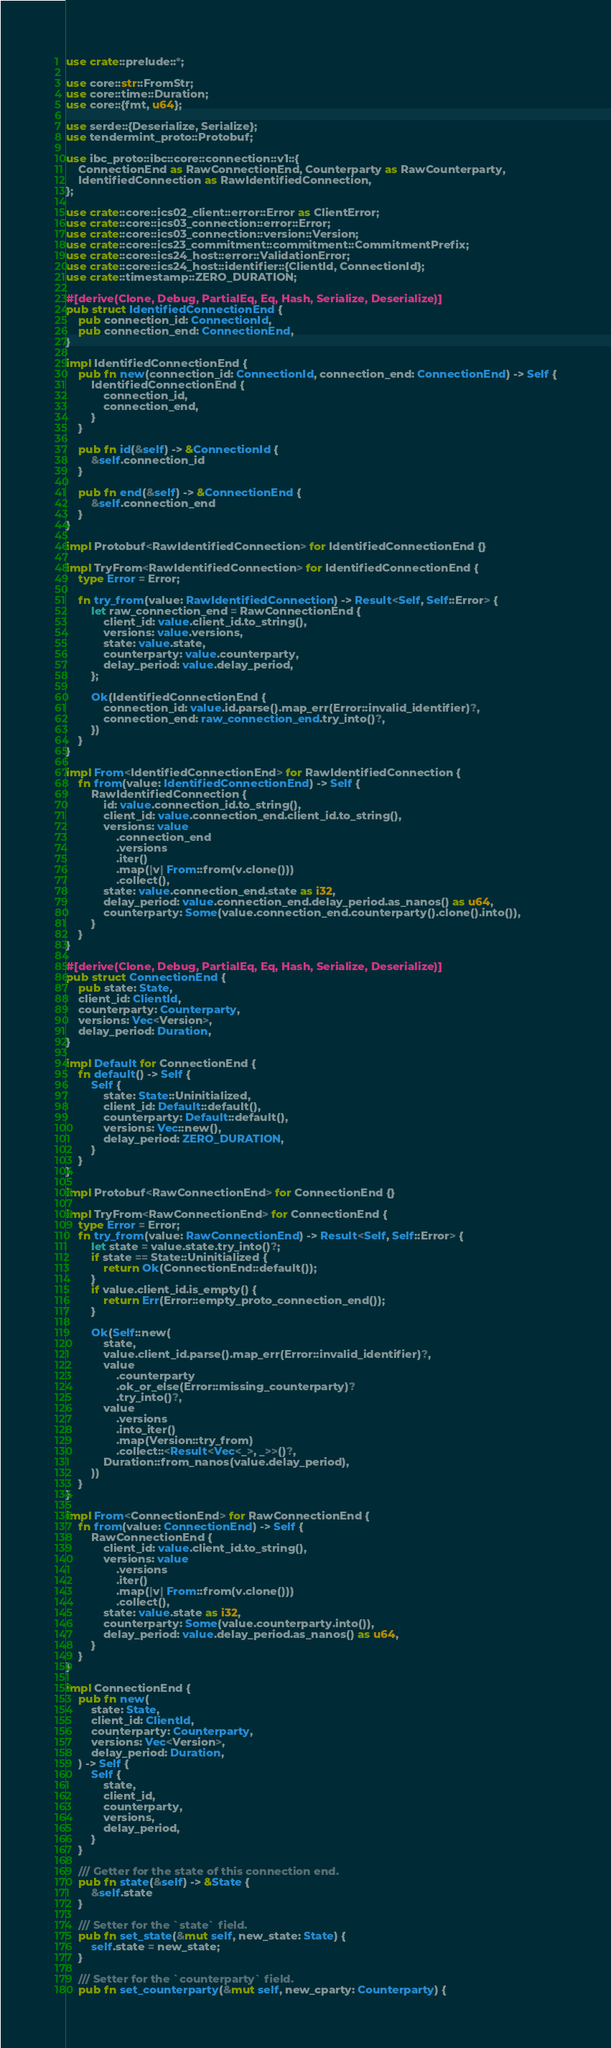Convert code to text. <code><loc_0><loc_0><loc_500><loc_500><_Rust_>use crate::prelude::*;

use core::str::FromStr;
use core::time::Duration;
use core::{fmt, u64};

use serde::{Deserialize, Serialize};
use tendermint_proto::Protobuf;

use ibc_proto::ibc::core::connection::v1::{
    ConnectionEnd as RawConnectionEnd, Counterparty as RawCounterparty,
    IdentifiedConnection as RawIdentifiedConnection,
};

use crate::core::ics02_client::error::Error as ClientError;
use crate::core::ics03_connection::error::Error;
use crate::core::ics03_connection::version::Version;
use crate::core::ics23_commitment::commitment::CommitmentPrefix;
use crate::core::ics24_host::error::ValidationError;
use crate::core::ics24_host::identifier::{ClientId, ConnectionId};
use crate::timestamp::ZERO_DURATION;

#[derive(Clone, Debug, PartialEq, Eq, Hash, Serialize, Deserialize)]
pub struct IdentifiedConnectionEnd {
    pub connection_id: ConnectionId,
    pub connection_end: ConnectionEnd,
}

impl IdentifiedConnectionEnd {
    pub fn new(connection_id: ConnectionId, connection_end: ConnectionEnd) -> Self {
        IdentifiedConnectionEnd {
            connection_id,
            connection_end,
        }
    }

    pub fn id(&self) -> &ConnectionId {
        &self.connection_id
    }

    pub fn end(&self) -> &ConnectionEnd {
        &self.connection_end
    }
}

impl Protobuf<RawIdentifiedConnection> for IdentifiedConnectionEnd {}

impl TryFrom<RawIdentifiedConnection> for IdentifiedConnectionEnd {
    type Error = Error;

    fn try_from(value: RawIdentifiedConnection) -> Result<Self, Self::Error> {
        let raw_connection_end = RawConnectionEnd {
            client_id: value.client_id.to_string(),
            versions: value.versions,
            state: value.state,
            counterparty: value.counterparty,
            delay_period: value.delay_period,
        };

        Ok(IdentifiedConnectionEnd {
            connection_id: value.id.parse().map_err(Error::invalid_identifier)?,
            connection_end: raw_connection_end.try_into()?,
        })
    }
}

impl From<IdentifiedConnectionEnd> for RawIdentifiedConnection {
    fn from(value: IdentifiedConnectionEnd) -> Self {
        RawIdentifiedConnection {
            id: value.connection_id.to_string(),
            client_id: value.connection_end.client_id.to_string(),
            versions: value
                .connection_end
                .versions
                .iter()
                .map(|v| From::from(v.clone()))
                .collect(),
            state: value.connection_end.state as i32,
            delay_period: value.connection_end.delay_period.as_nanos() as u64,
            counterparty: Some(value.connection_end.counterparty().clone().into()),
        }
    }
}

#[derive(Clone, Debug, PartialEq, Eq, Hash, Serialize, Deserialize)]
pub struct ConnectionEnd {
    pub state: State,
    client_id: ClientId,
    counterparty: Counterparty,
    versions: Vec<Version>,
    delay_period: Duration,
}

impl Default for ConnectionEnd {
    fn default() -> Self {
        Self {
            state: State::Uninitialized,
            client_id: Default::default(),
            counterparty: Default::default(),
            versions: Vec::new(),
            delay_period: ZERO_DURATION,
        }
    }
}

impl Protobuf<RawConnectionEnd> for ConnectionEnd {}

impl TryFrom<RawConnectionEnd> for ConnectionEnd {
    type Error = Error;
    fn try_from(value: RawConnectionEnd) -> Result<Self, Self::Error> {
        let state = value.state.try_into()?;
        if state == State::Uninitialized {
            return Ok(ConnectionEnd::default());
        }
        if value.client_id.is_empty() {
            return Err(Error::empty_proto_connection_end());
        }

        Ok(Self::new(
            state,
            value.client_id.parse().map_err(Error::invalid_identifier)?,
            value
                .counterparty
                .ok_or_else(Error::missing_counterparty)?
                .try_into()?,
            value
                .versions
                .into_iter()
                .map(Version::try_from)
                .collect::<Result<Vec<_>, _>>()?,
            Duration::from_nanos(value.delay_period),
        ))
    }
}

impl From<ConnectionEnd> for RawConnectionEnd {
    fn from(value: ConnectionEnd) -> Self {
        RawConnectionEnd {
            client_id: value.client_id.to_string(),
            versions: value
                .versions
                .iter()
                .map(|v| From::from(v.clone()))
                .collect(),
            state: value.state as i32,
            counterparty: Some(value.counterparty.into()),
            delay_period: value.delay_period.as_nanos() as u64,
        }
    }
}

impl ConnectionEnd {
    pub fn new(
        state: State,
        client_id: ClientId,
        counterparty: Counterparty,
        versions: Vec<Version>,
        delay_period: Duration,
    ) -> Self {
        Self {
            state,
            client_id,
            counterparty,
            versions,
            delay_period,
        }
    }

    /// Getter for the state of this connection end.
    pub fn state(&self) -> &State {
        &self.state
    }

    /// Setter for the `state` field.
    pub fn set_state(&mut self, new_state: State) {
        self.state = new_state;
    }

    /// Setter for the `counterparty` field.
    pub fn set_counterparty(&mut self, new_cparty: Counterparty) {</code> 